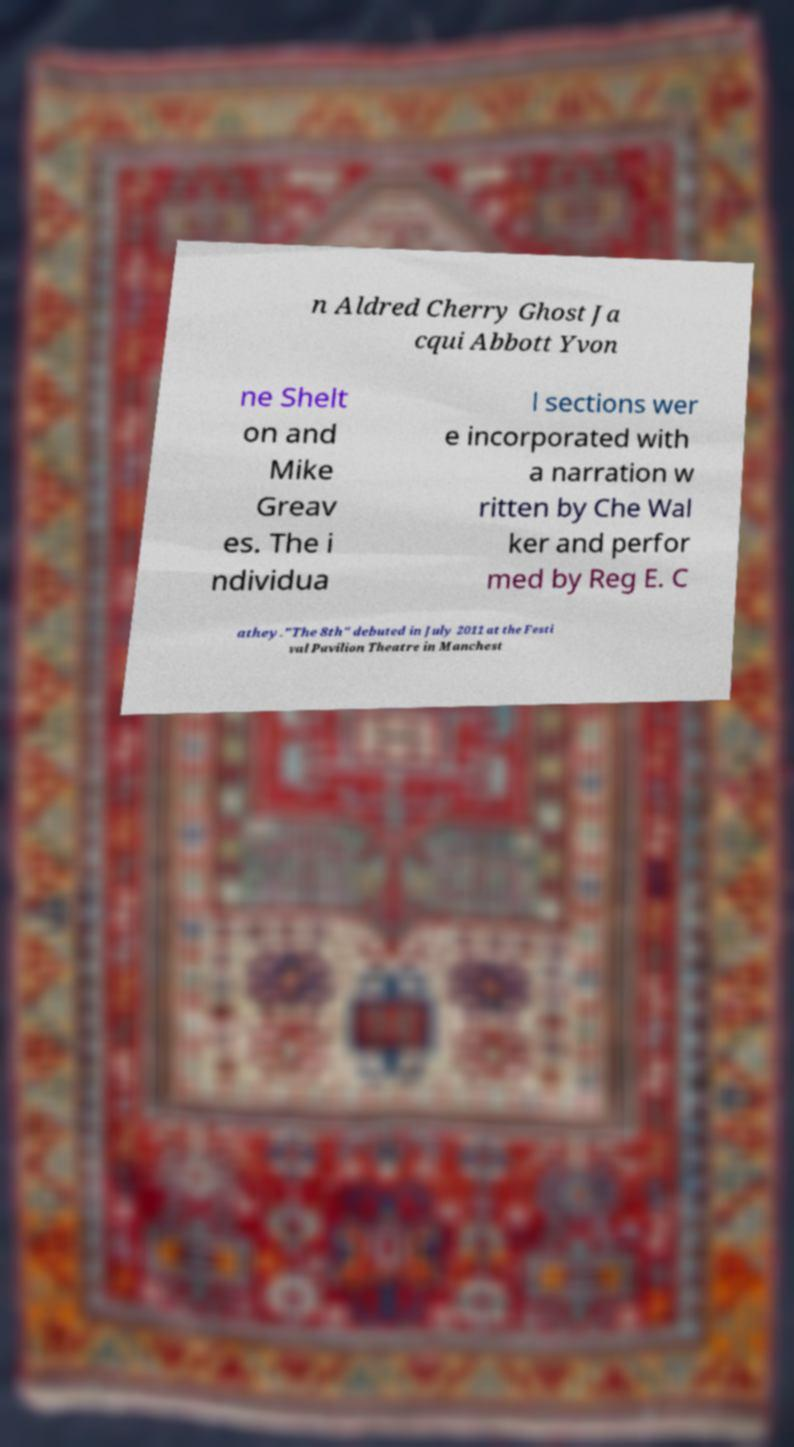Please identify and transcribe the text found in this image. n Aldred Cherry Ghost Ja cqui Abbott Yvon ne Shelt on and Mike Greav es. The i ndividua l sections wer e incorporated with a narration w ritten by Che Wal ker and perfor med by Reg E. C athey."The 8th" debuted in July 2011 at the Festi val Pavilion Theatre in Manchest 